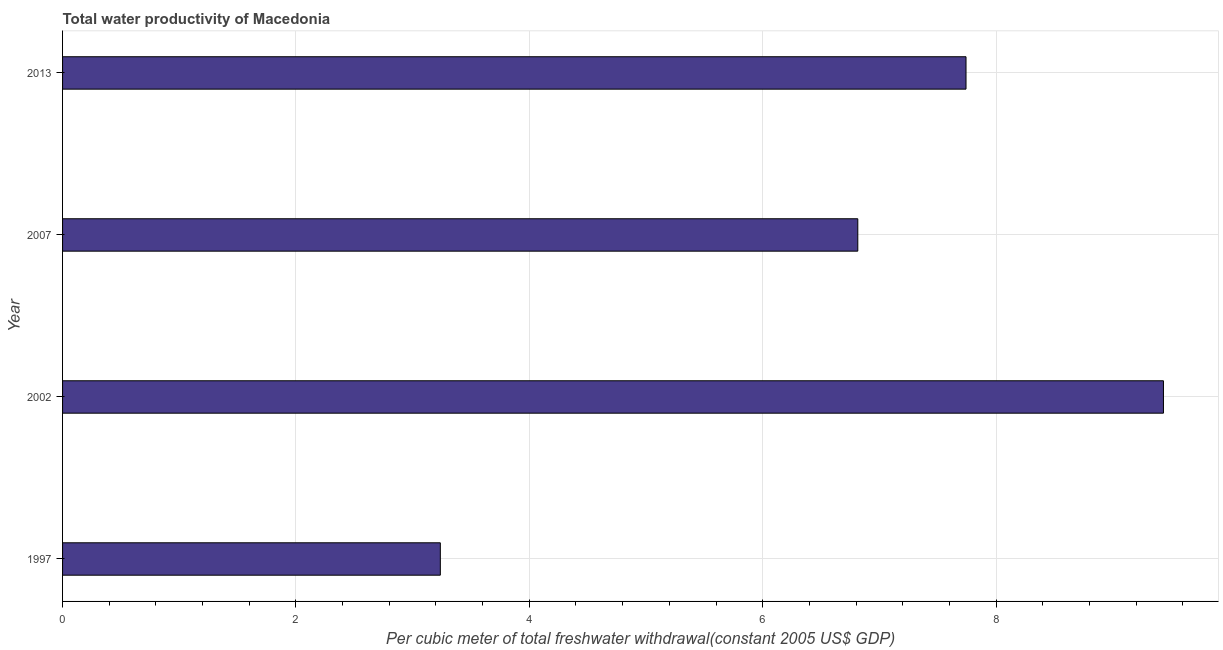Does the graph contain any zero values?
Keep it short and to the point. No. Does the graph contain grids?
Keep it short and to the point. Yes. What is the title of the graph?
Your response must be concise. Total water productivity of Macedonia. What is the label or title of the X-axis?
Your answer should be compact. Per cubic meter of total freshwater withdrawal(constant 2005 US$ GDP). What is the label or title of the Y-axis?
Offer a very short reply. Year. What is the total water productivity in 1997?
Your answer should be very brief. 3.24. Across all years, what is the maximum total water productivity?
Provide a short and direct response. 9.43. Across all years, what is the minimum total water productivity?
Provide a short and direct response. 3.24. In which year was the total water productivity maximum?
Give a very brief answer. 2002. In which year was the total water productivity minimum?
Your answer should be compact. 1997. What is the sum of the total water productivity?
Give a very brief answer. 27.23. What is the difference between the total water productivity in 1997 and 2007?
Your answer should be very brief. -3.58. What is the average total water productivity per year?
Keep it short and to the point. 6.81. What is the median total water productivity?
Ensure brevity in your answer.  7.28. In how many years, is the total water productivity greater than 0.8 US$?
Keep it short and to the point. 4. What is the ratio of the total water productivity in 1997 to that in 2007?
Offer a very short reply. 0.47. What is the difference between the highest and the second highest total water productivity?
Ensure brevity in your answer.  1.69. In how many years, is the total water productivity greater than the average total water productivity taken over all years?
Offer a very short reply. 3. How many years are there in the graph?
Give a very brief answer. 4. What is the Per cubic meter of total freshwater withdrawal(constant 2005 US$ GDP) of 1997?
Offer a very short reply. 3.24. What is the Per cubic meter of total freshwater withdrawal(constant 2005 US$ GDP) of 2002?
Offer a terse response. 9.43. What is the Per cubic meter of total freshwater withdrawal(constant 2005 US$ GDP) of 2007?
Give a very brief answer. 6.82. What is the Per cubic meter of total freshwater withdrawal(constant 2005 US$ GDP) of 2013?
Provide a succinct answer. 7.74. What is the difference between the Per cubic meter of total freshwater withdrawal(constant 2005 US$ GDP) in 1997 and 2002?
Provide a short and direct response. -6.2. What is the difference between the Per cubic meter of total freshwater withdrawal(constant 2005 US$ GDP) in 1997 and 2007?
Provide a succinct answer. -3.58. What is the difference between the Per cubic meter of total freshwater withdrawal(constant 2005 US$ GDP) in 1997 and 2013?
Give a very brief answer. -4.51. What is the difference between the Per cubic meter of total freshwater withdrawal(constant 2005 US$ GDP) in 2002 and 2007?
Your answer should be very brief. 2.62. What is the difference between the Per cubic meter of total freshwater withdrawal(constant 2005 US$ GDP) in 2002 and 2013?
Provide a short and direct response. 1.69. What is the difference between the Per cubic meter of total freshwater withdrawal(constant 2005 US$ GDP) in 2007 and 2013?
Your answer should be compact. -0.93. What is the ratio of the Per cubic meter of total freshwater withdrawal(constant 2005 US$ GDP) in 1997 to that in 2002?
Your response must be concise. 0.34. What is the ratio of the Per cubic meter of total freshwater withdrawal(constant 2005 US$ GDP) in 1997 to that in 2007?
Your answer should be very brief. 0.47. What is the ratio of the Per cubic meter of total freshwater withdrawal(constant 2005 US$ GDP) in 1997 to that in 2013?
Keep it short and to the point. 0.42. What is the ratio of the Per cubic meter of total freshwater withdrawal(constant 2005 US$ GDP) in 2002 to that in 2007?
Offer a terse response. 1.38. What is the ratio of the Per cubic meter of total freshwater withdrawal(constant 2005 US$ GDP) in 2002 to that in 2013?
Make the answer very short. 1.22. What is the ratio of the Per cubic meter of total freshwater withdrawal(constant 2005 US$ GDP) in 2007 to that in 2013?
Offer a terse response. 0.88. 